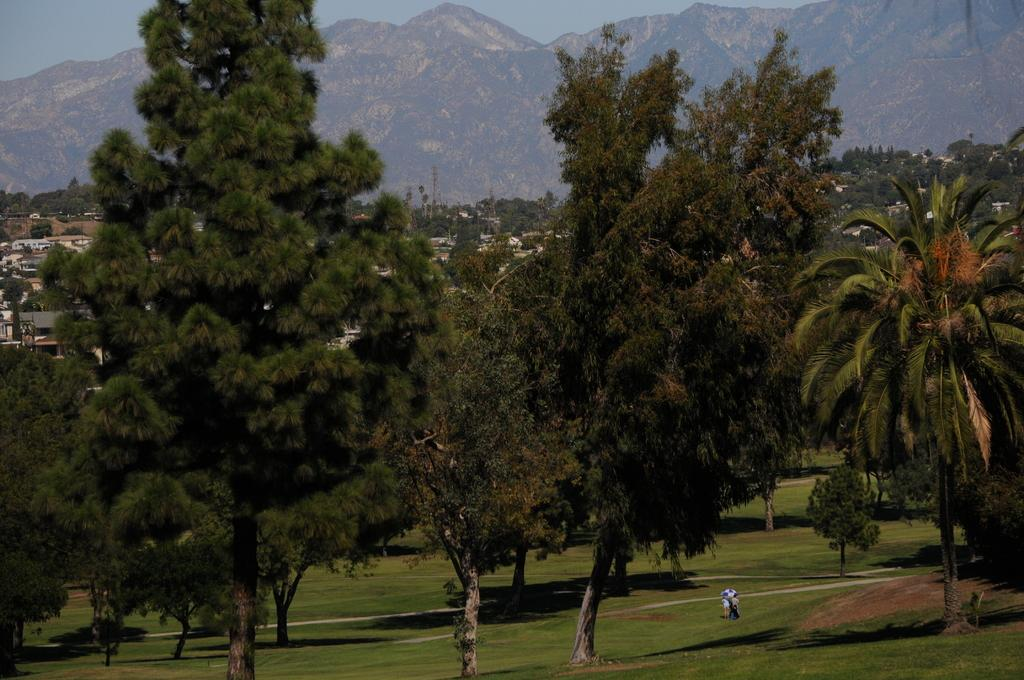What type of vegetation is present in the image? There is grass in the image. How many people can be seen on the ground in the image? There are three persons on the ground in the image. What other natural elements are visible in the image? There are trees in the image. What type of structures can be seen in the image? There are houses in the image. What geographical feature is visible in the image? There is a mountain in the image. What is visible in the background of the image? The sky is visible in the background of the image. What type of potato is being used as a symbol of authority in the image? There is no potato or symbol of authority present in the image. Is there any rain visible in the image? There is no rain visible in the image. 